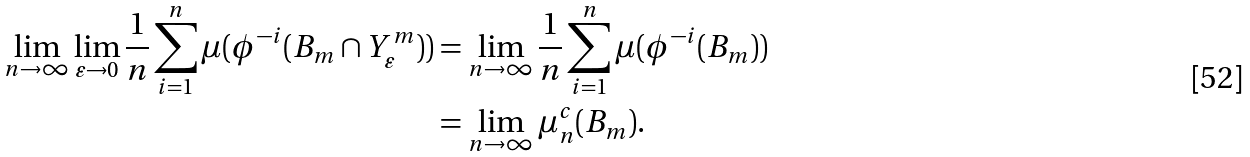Convert formula to latex. <formula><loc_0><loc_0><loc_500><loc_500>\lim _ { n \rightarrow \infty } \lim _ { \varepsilon \rightarrow 0 } \frac { 1 } { n } \sum _ { i = 1 } ^ { n } \mu ( \phi ^ { - i } ( B _ { m } \cap Y _ { \varepsilon } ^ { m } ) ) & = \lim _ { n \rightarrow \infty } \frac { 1 } { n } \sum _ { i = 1 } ^ { n } \mu ( \phi ^ { - i } ( B _ { m } ) ) \\ & = \lim _ { n \rightarrow \infty } \mu _ { n } ^ { c } ( B _ { m } ) .</formula> 